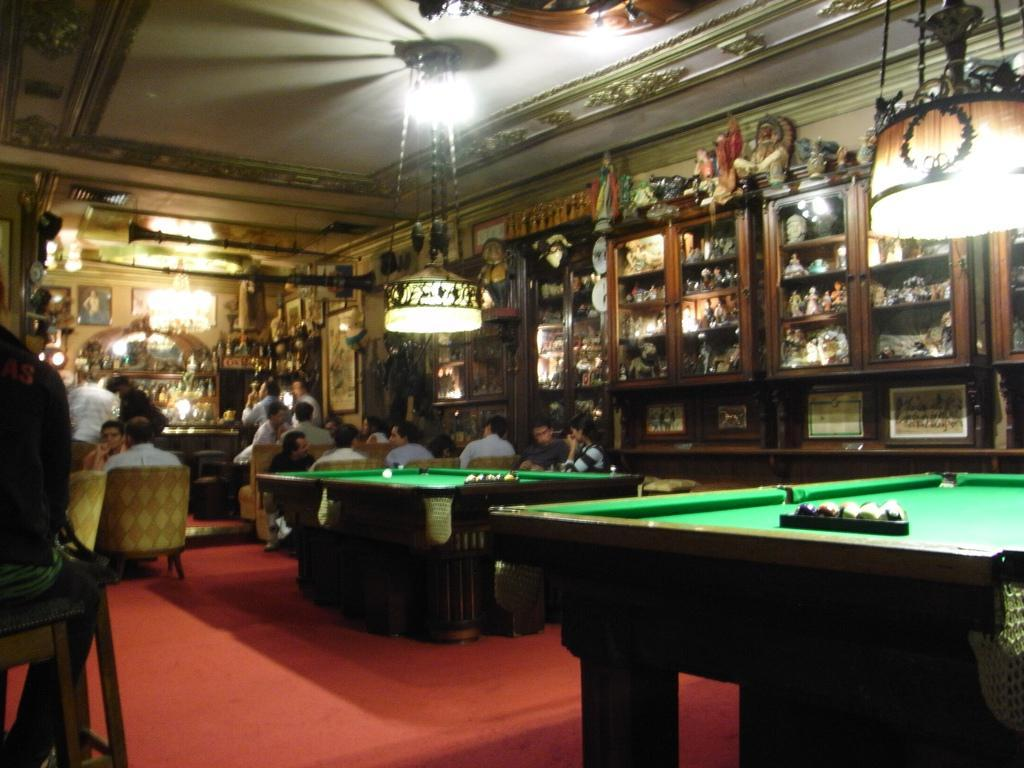What type of space is shown in the image? There is a room in the image. What is happening in the room? There is a group of people in the room. How are the people positioned in the room? The people are sitting on chairs. What can be seen in the background of the room? There are lights, a cupboard, and the roof visible in the background. What type of protest is happening outside the room in the image? There is no protest visible in the image; it only shows a room with people sitting on chairs. Can you tell me how many waves are crashing against the shore in the image? There is no shore or waves present in the image; it only shows a room with people sitting on chairs. 